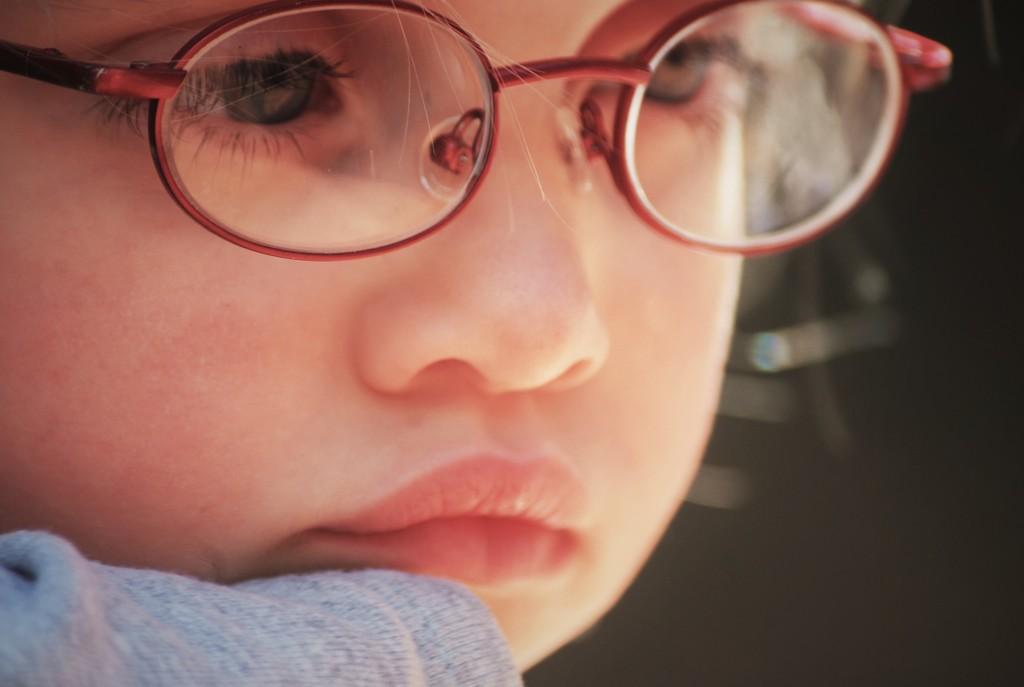What is the main subject of the image? The main subject of the image is a kid. How close is the camera to the kid in the image? The image is a zoomed-in picture of the kid. What can be observed about the background in the image? The background of the kid is blurred. What type of effect does the visitor have on the noise level in the image? There is no visitor present in the image, and therefore no such effect can be observed. 